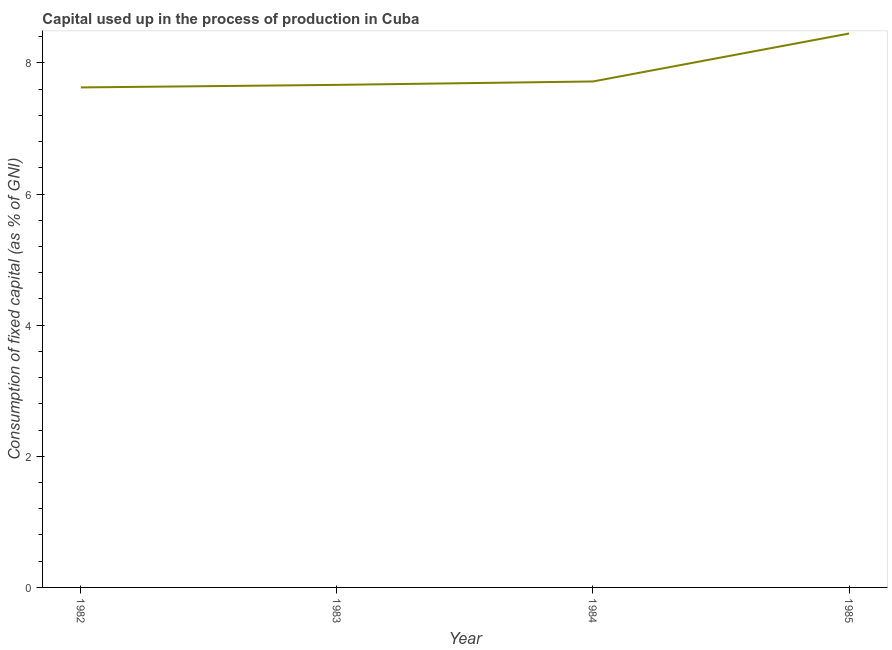What is the consumption of fixed capital in 1983?
Offer a very short reply. 7.67. Across all years, what is the maximum consumption of fixed capital?
Offer a terse response. 8.45. Across all years, what is the minimum consumption of fixed capital?
Provide a succinct answer. 7.63. In which year was the consumption of fixed capital maximum?
Your answer should be very brief. 1985. In which year was the consumption of fixed capital minimum?
Make the answer very short. 1982. What is the sum of the consumption of fixed capital?
Your answer should be compact. 31.46. What is the difference between the consumption of fixed capital in 1982 and 1983?
Provide a succinct answer. -0.04. What is the average consumption of fixed capital per year?
Offer a very short reply. 7.86. What is the median consumption of fixed capital?
Your answer should be very brief. 7.69. In how many years, is the consumption of fixed capital greater than 0.4 %?
Offer a terse response. 4. Do a majority of the years between 1982 and 1983 (inclusive) have consumption of fixed capital greater than 2.4 %?
Offer a terse response. Yes. What is the ratio of the consumption of fixed capital in 1982 to that in 1984?
Offer a very short reply. 0.99. Is the difference between the consumption of fixed capital in 1982 and 1985 greater than the difference between any two years?
Ensure brevity in your answer.  Yes. What is the difference between the highest and the second highest consumption of fixed capital?
Give a very brief answer. 0.73. Is the sum of the consumption of fixed capital in 1982 and 1985 greater than the maximum consumption of fixed capital across all years?
Offer a very short reply. Yes. What is the difference between the highest and the lowest consumption of fixed capital?
Offer a very short reply. 0.82. Does the consumption of fixed capital monotonically increase over the years?
Offer a terse response. Yes. How many lines are there?
Keep it short and to the point. 1. How many years are there in the graph?
Provide a short and direct response. 4. Are the values on the major ticks of Y-axis written in scientific E-notation?
Your answer should be very brief. No. What is the title of the graph?
Provide a short and direct response. Capital used up in the process of production in Cuba. What is the label or title of the Y-axis?
Your answer should be very brief. Consumption of fixed capital (as % of GNI). What is the Consumption of fixed capital (as % of GNI) of 1982?
Give a very brief answer. 7.63. What is the Consumption of fixed capital (as % of GNI) of 1983?
Your response must be concise. 7.67. What is the Consumption of fixed capital (as % of GNI) in 1984?
Your answer should be compact. 7.72. What is the Consumption of fixed capital (as % of GNI) in 1985?
Give a very brief answer. 8.45. What is the difference between the Consumption of fixed capital (as % of GNI) in 1982 and 1983?
Offer a very short reply. -0.04. What is the difference between the Consumption of fixed capital (as % of GNI) in 1982 and 1984?
Your response must be concise. -0.09. What is the difference between the Consumption of fixed capital (as % of GNI) in 1982 and 1985?
Your answer should be compact. -0.82. What is the difference between the Consumption of fixed capital (as % of GNI) in 1983 and 1984?
Offer a terse response. -0.05. What is the difference between the Consumption of fixed capital (as % of GNI) in 1983 and 1985?
Provide a succinct answer. -0.78. What is the difference between the Consumption of fixed capital (as % of GNI) in 1984 and 1985?
Keep it short and to the point. -0.73. What is the ratio of the Consumption of fixed capital (as % of GNI) in 1982 to that in 1983?
Your response must be concise. 0.99. What is the ratio of the Consumption of fixed capital (as % of GNI) in 1982 to that in 1985?
Your answer should be compact. 0.9. What is the ratio of the Consumption of fixed capital (as % of GNI) in 1983 to that in 1985?
Your answer should be very brief. 0.91. 